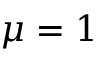<formula> <loc_0><loc_0><loc_500><loc_500>\mu = 1</formula> 